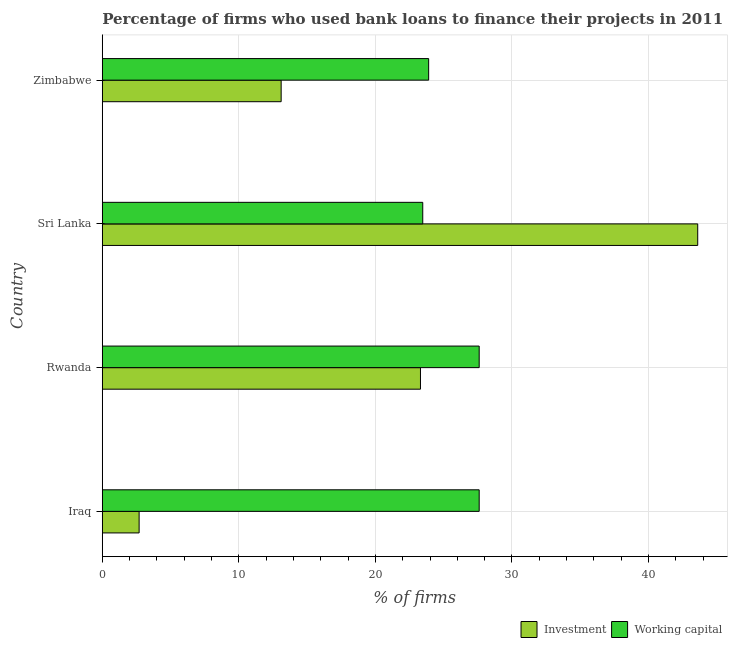How many different coloured bars are there?
Provide a succinct answer. 2. Are the number of bars per tick equal to the number of legend labels?
Provide a succinct answer. Yes. How many bars are there on the 2nd tick from the top?
Provide a short and direct response. 2. How many bars are there on the 4th tick from the bottom?
Make the answer very short. 2. What is the label of the 4th group of bars from the top?
Make the answer very short. Iraq. In how many cases, is the number of bars for a given country not equal to the number of legend labels?
Give a very brief answer. 0. What is the percentage of firms using banks to finance working capital in Sri Lanka?
Offer a terse response. 23.47. Across all countries, what is the maximum percentage of firms using banks to finance working capital?
Your answer should be very brief. 27.6. Across all countries, what is the minimum percentage of firms using banks to finance working capital?
Offer a terse response. 23.47. In which country was the percentage of firms using banks to finance working capital maximum?
Provide a short and direct response. Iraq. In which country was the percentage of firms using banks to finance investment minimum?
Offer a very short reply. Iraq. What is the total percentage of firms using banks to finance investment in the graph?
Provide a succinct answer. 82.7. What is the difference between the percentage of firms using banks to finance investment in Zimbabwe and the percentage of firms using banks to finance working capital in Iraq?
Keep it short and to the point. -14.5. What is the average percentage of firms using banks to finance working capital per country?
Keep it short and to the point. 25.64. What is the difference between the percentage of firms using banks to finance investment and percentage of firms using banks to finance working capital in Iraq?
Provide a succinct answer. -24.9. What is the ratio of the percentage of firms using banks to finance working capital in Iraq to that in Zimbabwe?
Your answer should be very brief. 1.16. Is the percentage of firms using banks to finance investment in Iraq less than that in Rwanda?
Make the answer very short. Yes. What is the difference between the highest and the lowest percentage of firms using banks to finance investment?
Offer a very short reply. 40.9. In how many countries, is the percentage of firms using banks to finance working capital greater than the average percentage of firms using banks to finance working capital taken over all countries?
Make the answer very short. 2. Is the sum of the percentage of firms using banks to finance working capital in Iraq and Rwanda greater than the maximum percentage of firms using banks to finance investment across all countries?
Your answer should be very brief. Yes. What does the 1st bar from the top in Iraq represents?
Your answer should be very brief. Working capital. What does the 1st bar from the bottom in Zimbabwe represents?
Ensure brevity in your answer.  Investment. Are the values on the major ticks of X-axis written in scientific E-notation?
Your answer should be very brief. No. Does the graph contain any zero values?
Keep it short and to the point. No. Where does the legend appear in the graph?
Provide a succinct answer. Bottom right. How many legend labels are there?
Provide a short and direct response. 2. How are the legend labels stacked?
Your answer should be compact. Horizontal. What is the title of the graph?
Make the answer very short. Percentage of firms who used bank loans to finance their projects in 2011. What is the label or title of the X-axis?
Keep it short and to the point. % of firms. What is the % of firms of Investment in Iraq?
Provide a short and direct response. 2.7. What is the % of firms of Working capital in Iraq?
Provide a succinct answer. 27.6. What is the % of firms of Investment in Rwanda?
Offer a terse response. 23.3. What is the % of firms in Working capital in Rwanda?
Your response must be concise. 27.6. What is the % of firms of Investment in Sri Lanka?
Your response must be concise. 43.6. What is the % of firms in Working capital in Sri Lanka?
Keep it short and to the point. 23.47. What is the % of firms in Investment in Zimbabwe?
Your answer should be very brief. 13.1. What is the % of firms of Working capital in Zimbabwe?
Your answer should be compact. 23.9. Across all countries, what is the maximum % of firms in Investment?
Ensure brevity in your answer.  43.6. Across all countries, what is the maximum % of firms in Working capital?
Give a very brief answer. 27.6. Across all countries, what is the minimum % of firms of Investment?
Your response must be concise. 2.7. Across all countries, what is the minimum % of firms of Working capital?
Your answer should be compact. 23.47. What is the total % of firms in Investment in the graph?
Offer a very short reply. 82.7. What is the total % of firms in Working capital in the graph?
Your answer should be compact. 102.57. What is the difference between the % of firms in Investment in Iraq and that in Rwanda?
Ensure brevity in your answer.  -20.6. What is the difference between the % of firms in Working capital in Iraq and that in Rwanda?
Keep it short and to the point. 0. What is the difference between the % of firms of Investment in Iraq and that in Sri Lanka?
Ensure brevity in your answer.  -40.9. What is the difference between the % of firms in Working capital in Iraq and that in Sri Lanka?
Your answer should be compact. 4.13. What is the difference between the % of firms of Investment in Iraq and that in Zimbabwe?
Keep it short and to the point. -10.4. What is the difference between the % of firms of Investment in Rwanda and that in Sri Lanka?
Your answer should be very brief. -20.3. What is the difference between the % of firms of Working capital in Rwanda and that in Sri Lanka?
Your answer should be very brief. 4.13. What is the difference between the % of firms in Investment in Rwanda and that in Zimbabwe?
Offer a very short reply. 10.2. What is the difference between the % of firms in Working capital in Rwanda and that in Zimbabwe?
Give a very brief answer. 3.7. What is the difference between the % of firms in Investment in Sri Lanka and that in Zimbabwe?
Make the answer very short. 30.5. What is the difference between the % of firms in Working capital in Sri Lanka and that in Zimbabwe?
Offer a terse response. -0.43. What is the difference between the % of firms in Investment in Iraq and the % of firms in Working capital in Rwanda?
Ensure brevity in your answer.  -24.9. What is the difference between the % of firms in Investment in Iraq and the % of firms in Working capital in Sri Lanka?
Provide a succinct answer. -20.77. What is the difference between the % of firms of Investment in Iraq and the % of firms of Working capital in Zimbabwe?
Your answer should be compact. -21.2. What is the difference between the % of firms of Investment in Rwanda and the % of firms of Working capital in Zimbabwe?
Give a very brief answer. -0.6. What is the average % of firms of Investment per country?
Offer a terse response. 20.68. What is the average % of firms of Working capital per country?
Your response must be concise. 25.64. What is the difference between the % of firms of Investment and % of firms of Working capital in Iraq?
Give a very brief answer. -24.9. What is the difference between the % of firms of Investment and % of firms of Working capital in Sri Lanka?
Your answer should be compact. 20.13. What is the difference between the % of firms of Investment and % of firms of Working capital in Zimbabwe?
Your answer should be very brief. -10.8. What is the ratio of the % of firms of Investment in Iraq to that in Rwanda?
Ensure brevity in your answer.  0.12. What is the ratio of the % of firms in Working capital in Iraq to that in Rwanda?
Offer a very short reply. 1. What is the ratio of the % of firms of Investment in Iraq to that in Sri Lanka?
Your answer should be very brief. 0.06. What is the ratio of the % of firms in Working capital in Iraq to that in Sri Lanka?
Ensure brevity in your answer.  1.18. What is the ratio of the % of firms of Investment in Iraq to that in Zimbabwe?
Keep it short and to the point. 0.21. What is the ratio of the % of firms in Working capital in Iraq to that in Zimbabwe?
Ensure brevity in your answer.  1.15. What is the ratio of the % of firms in Investment in Rwanda to that in Sri Lanka?
Keep it short and to the point. 0.53. What is the ratio of the % of firms of Working capital in Rwanda to that in Sri Lanka?
Ensure brevity in your answer.  1.18. What is the ratio of the % of firms of Investment in Rwanda to that in Zimbabwe?
Your answer should be compact. 1.78. What is the ratio of the % of firms in Working capital in Rwanda to that in Zimbabwe?
Keep it short and to the point. 1.15. What is the ratio of the % of firms of Investment in Sri Lanka to that in Zimbabwe?
Provide a succinct answer. 3.33. What is the ratio of the % of firms of Working capital in Sri Lanka to that in Zimbabwe?
Offer a very short reply. 0.98. What is the difference between the highest and the second highest % of firms in Investment?
Your response must be concise. 20.3. What is the difference between the highest and the second highest % of firms of Working capital?
Offer a terse response. 0. What is the difference between the highest and the lowest % of firms in Investment?
Keep it short and to the point. 40.9. What is the difference between the highest and the lowest % of firms of Working capital?
Keep it short and to the point. 4.13. 